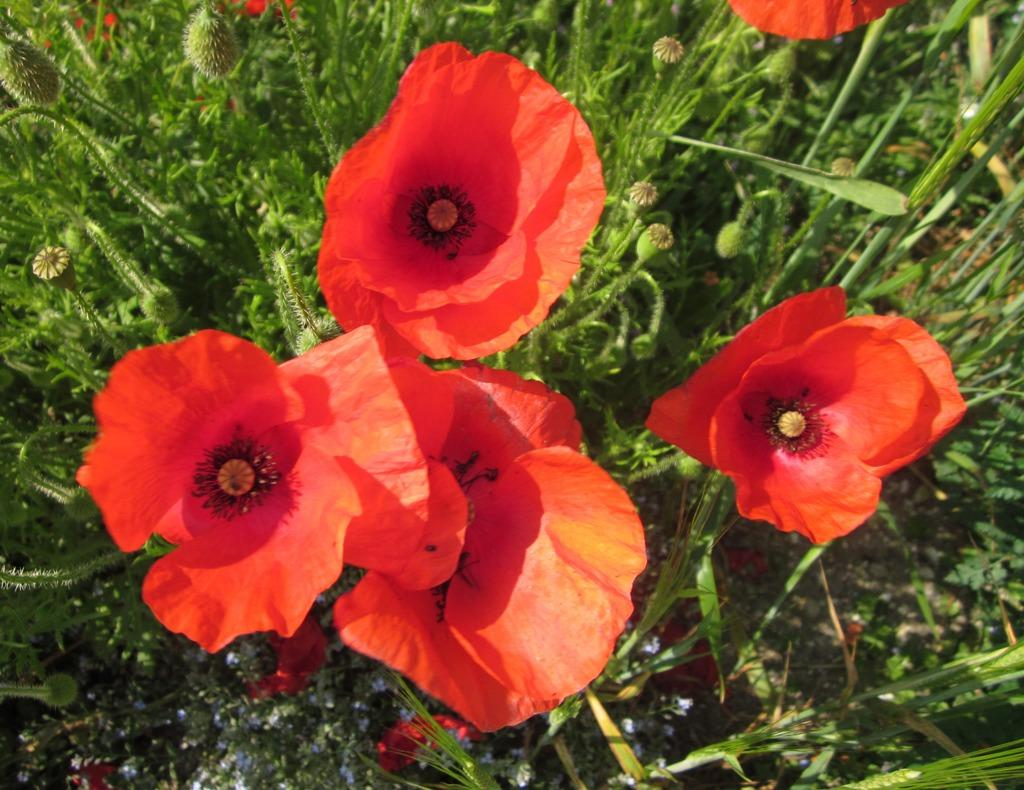What type of living organisms can be seen in the image? There are flowers and plants in the image. Can you describe the plants in the image? The plants in the image are not specified, but they are present alongside the flowers. What type of drink is being served in the image? There is no drink present in the image; it features flowers and plants. Can you provide an example of a plane in the image? There is no plane present in the image; it only contains flowers and plants. 